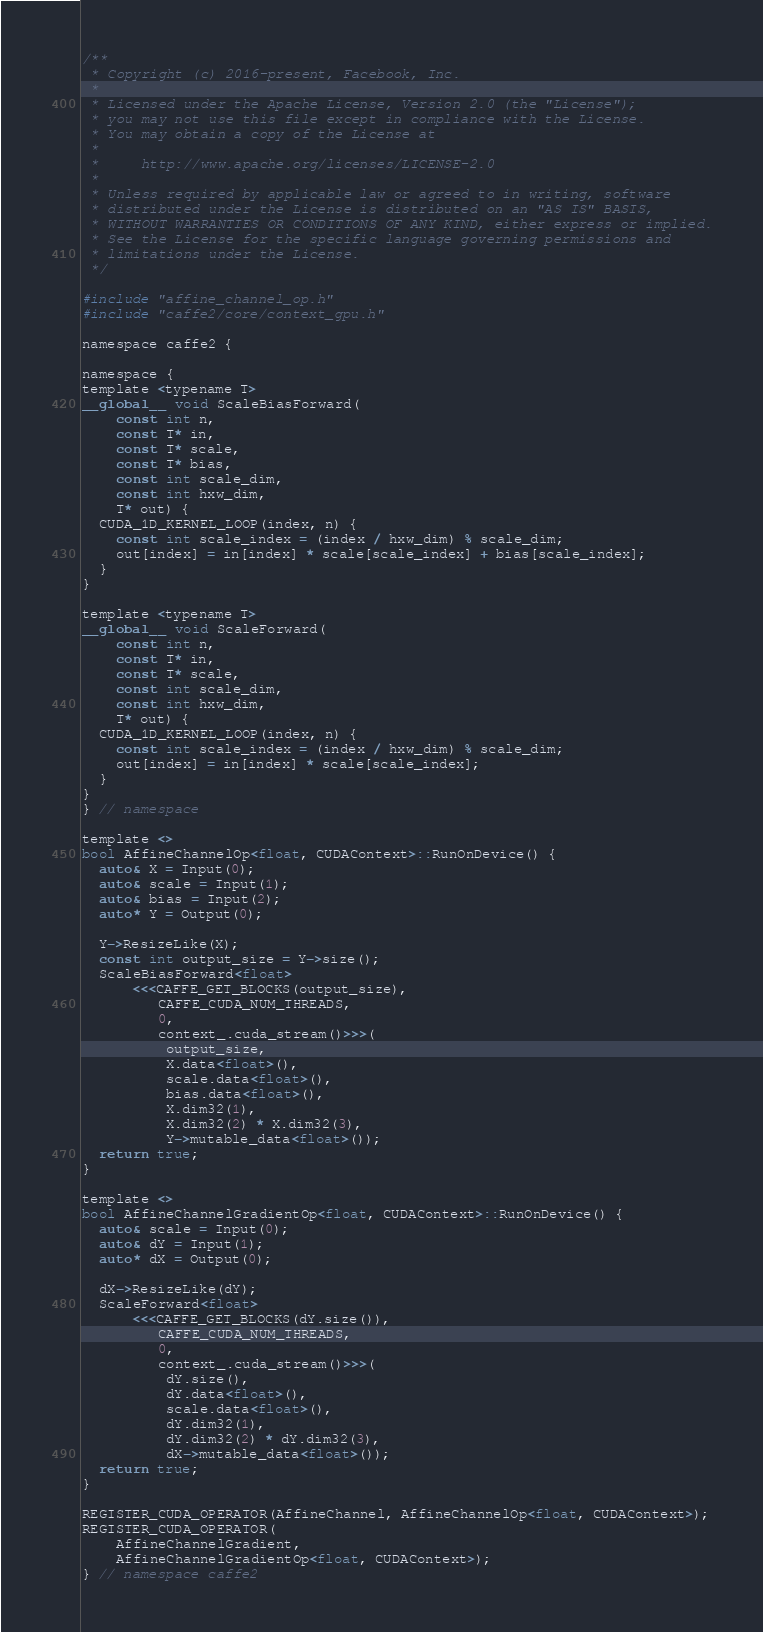<code> <loc_0><loc_0><loc_500><loc_500><_Cuda_>/**
 * Copyright (c) 2016-present, Facebook, Inc.
 *
 * Licensed under the Apache License, Version 2.0 (the "License");
 * you may not use this file except in compliance with the License.
 * You may obtain a copy of the License at
 *
 *     http://www.apache.org/licenses/LICENSE-2.0
 *
 * Unless required by applicable law or agreed to in writing, software
 * distributed under the License is distributed on an "AS IS" BASIS,
 * WITHOUT WARRANTIES OR CONDITIONS OF ANY KIND, either express or implied.
 * See the License for the specific language governing permissions and
 * limitations under the License.
 */

#include "affine_channel_op.h"
#include "caffe2/core/context_gpu.h"

namespace caffe2 {

namespace {
template <typename T>
__global__ void ScaleBiasForward(
    const int n,
    const T* in,
    const T* scale,
    const T* bias,
    const int scale_dim,
    const int hxw_dim,
    T* out) {
  CUDA_1D_KERNEL_LOOP(index, n) {
    const int scale_index = (index / hxw_dim) % scale_dim;
    out[index] = in[index] * scale[scale_index] + bias[scale_index];
  }
}

template <typename T>
__global__ void ScaleForward(
    const int n,
    const T* in,
    const T* scale,
    const int scale_dim,
    const int hxw_dim,
    T* out) {
  CUDA_1D_KERNEL_LOOP(index, n) {
    const int scale_index = (index / hxw_dim) % scale_dim;
    out[index] = in[index] * scale[scale_index];
  }
}
} // namespace

template <>
bool AffineChannelOp<float, CUDAContext>::RunOnDevice() {
  auto& X = Input(0);
  auto& scale = Input(1);
  auto& bias = Input(2);
  auto* Y = Output(0);

  Y->ResizeLike(X);
  const int output_size = Y->size();
  ScaleBiasForward<float>
      <<<CAFFE_GET_BLOCKS(output_size),
         CAFFE_CUDA_NUM_THREADS,
         0,
         context_.cuda_stream()>>>(
          output_size,
          X.data<float>(),
          scale.data<float>(),
          bias.data<float>(),
          X.dim32(1),
          X.dim32(2) * X.dim32(3),
          Y->mutable_data<float>());
  return true;
}

template <>
bool AffineChannelGradientOp<float, CUDAContext>::RunOnDevice() {
  auto& scale = Input(0);
  auto& dY = Input(1);
  auto* dX = Output(0);

  dX->ResizeLike(dY);
  ScaleForward<float>
      <<<CAFFE_GET_BLOCKS(dY.size()),
         CAFFE_CUDA_NUM_THREADS,
         0,
         context_.cuda_stream()>>>(
          dY.size(),
          dY.data<float>(),
          scale.data<float>(),
          dY.dim32(1),
          dY.dim32(2) * dY.dim32(3),
          dX->mutable_data<float>());
  return true;
}

REGISTER_CUDA_OPERATOR(AffineChannel, AffineChannelOp<float, CUDAContext>);
REGISTER_CUDA_OPERATOR(
    AffineChannelGradient,
    AffineChannelGradientOp<float, CUDAContext>);
} // namespace caffe2
</code> 